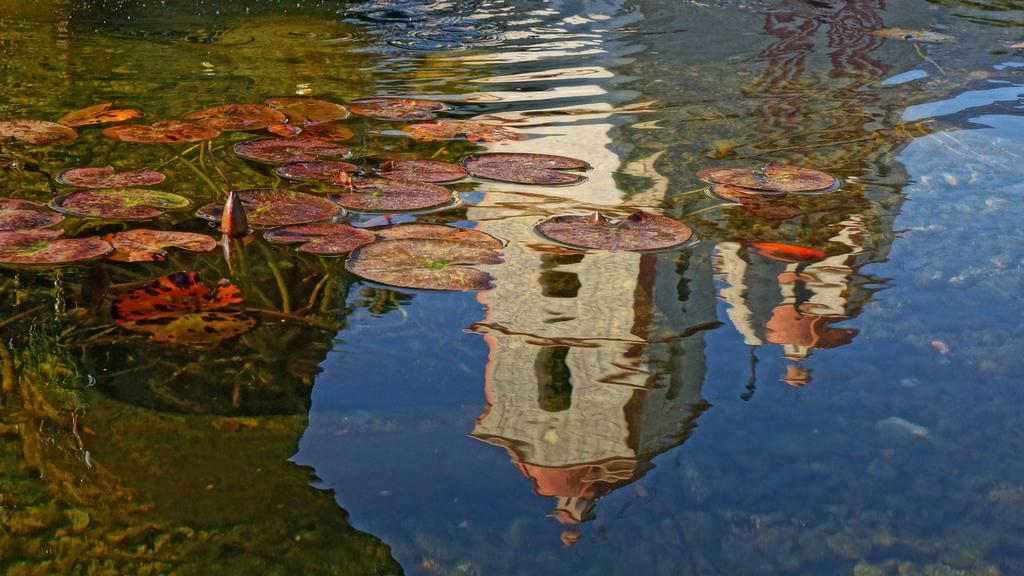What type of plant material can be seen in the image? There are leaves and a bud in the image. Where are the leaves and bud located? The leaves and bud are on the water. What is visible in the water's reflection? There is a reflection of a building in the water. What type of plough is being used to fold the leaves in the image? There is no plough or folding action involving the leaves in the image. 